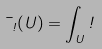Convert formula to latex. <formula><loc_0><loc_0><loc_500><loc_500>\mu _ { \omega } ( U ) = \int _ { U } \omega</formula> 